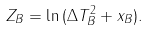<formula> <loc_0><loc_0><loc_500><loc_500>Z _ { B } = \ln { ( \Delta T ^ { 2 } _ { B } + x _ { B } ) } .</formula> 